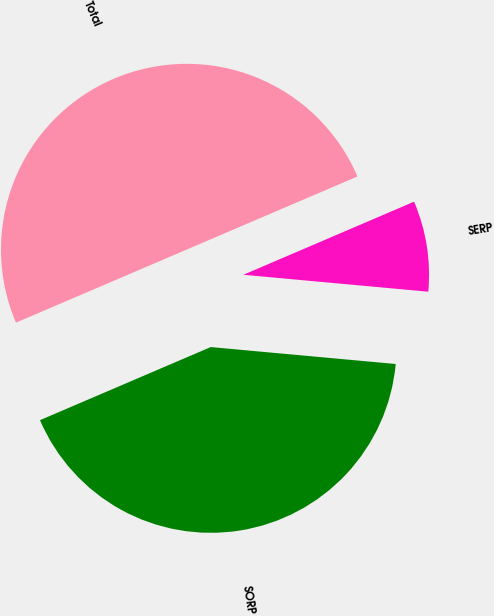Convert chart. <chart><loc_0><loc_0><loc_500><loc_500><pie_chart><fcel>SORP<fcel>SERP<fcel>Total<nl><fcel>42.11%<fcel>7.89%<fcel>50.0%<nl></chart> 